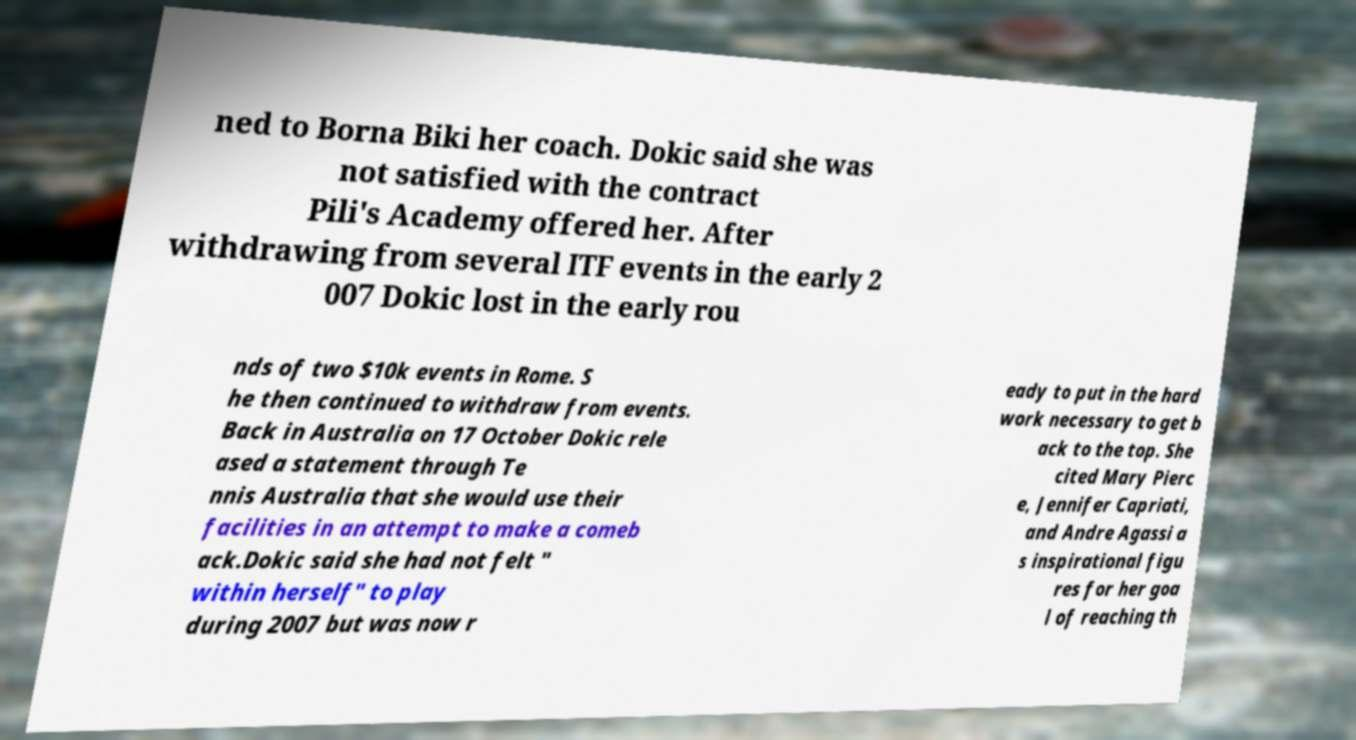There's text embedded in this image that I need extracted. Can you transcribe it verbatim? ned to Borna Biki her coach. Dokic said she was not satisfied with the contract Pili's Academy offered her. After withdrawing from several ITF events in the early 2 007 Dokic lost in the early rou nds of two $10k events in Rome. S he then continued to withdraw from events. Back in Australia on 17 October Dokic rele ased a statement through Te nnis Australia that she would use their facilities in an attempt to make a comeb ack.Dokic said she had not felt " within herself" to play during 2007 but was now r eady to put in the hard work necessary to get b ack to the top. She cited Mary Pierc e, Jennifer Capriati, and Andre Agassi a s inspirational figu res for her goa l of reaching th 